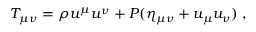<formula> <loc_0><loc_0><loc_500><loc_500>T _ { \mu \nu } = \rho u ^ { \mu } u ^ { \nu } + P ( \eta _ { \mu \nu } + u _ { \mu } u _ { \nu } ) \, ,</formula> 